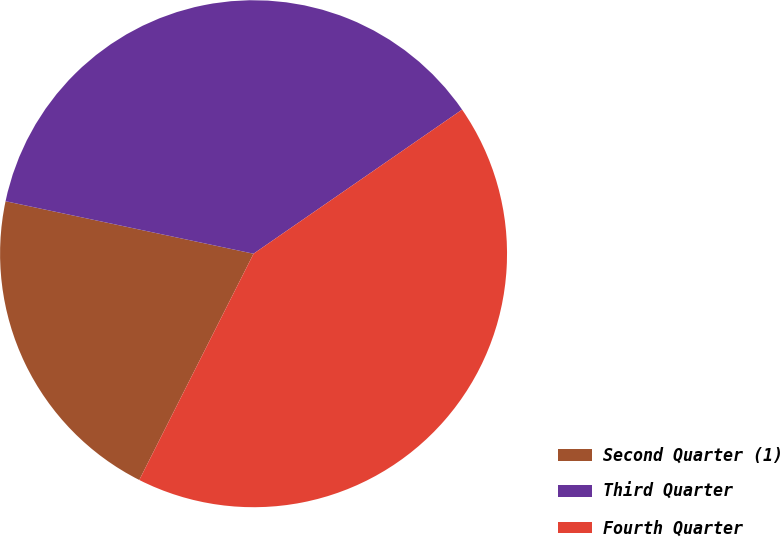Convert chart. <chart><loc_0><loc_0><loc_500><loc_500><pie_chart><fcel>Second Quarter (1)<fcel>Third Quarter<fcel>Fourth Quarter<nl><fcel>20.88%<fcel>37.06%<fcel>42.07%<nl></chart> 